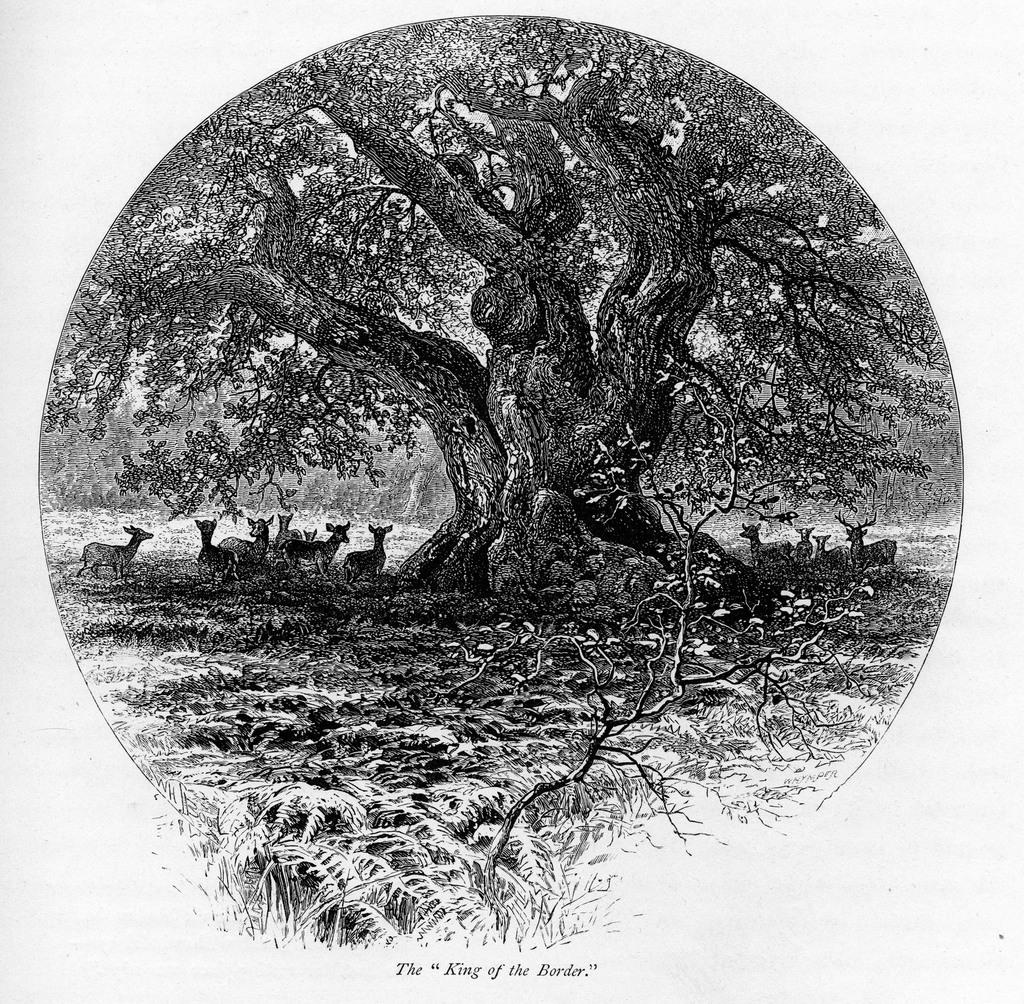What is the color scheme of the image? The image is black and white. What can be seen within the image? There is a picture within the image. What is depicted in the picture? The picture contains trees and a herd of animals. Where are the animals located in the picture? The herd is standing on the ground. What type of mind can be seen in the image? There is no mind present in the image; it contains a picture with trees and a herd of animals. How many crows are visible in the image? There are no crows present in the image. 